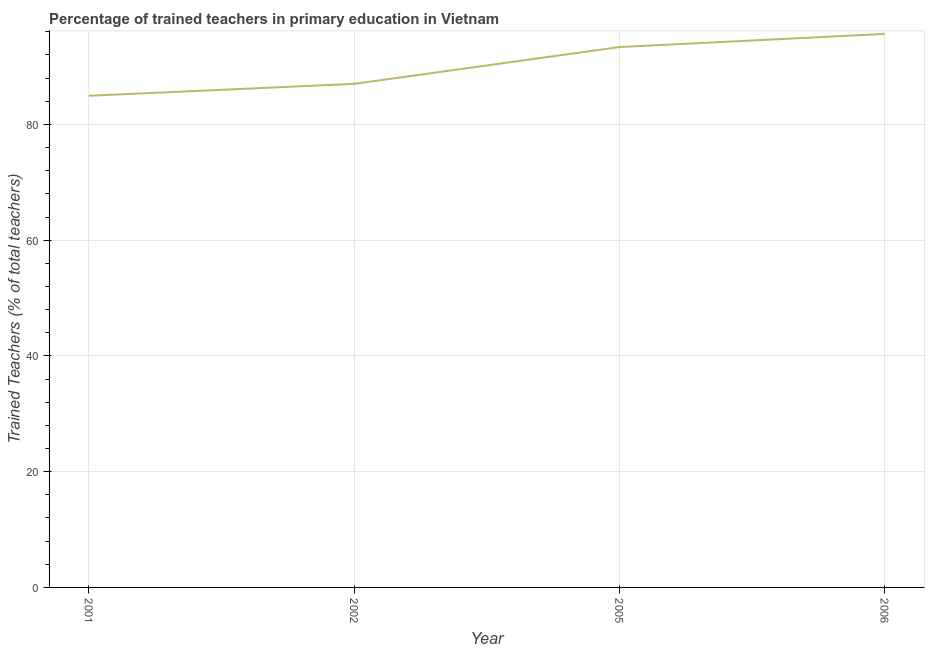What is the percentage of trained teachers in 2002?
Your answer should be compact. 87.01. Across all years, what is the maximum percentage of trained teachers?
Provide a succinct answer. 95.64. Across all years, what is the minimum percentage of trained teachers?
Ensure brevity in your answer.  84.95. In which year was the percentage of trained teachers maximum?
Your answer should be very brief. 2006. In which year was the percentage of trained teachers minimum?
Offer a terse response. 2001. What is the sum of the percentage of trained teachers?
Your answer should be very brief. 360.97. What is the difference between the percentage of trained teachers in 2002 and 2006?
Offer a very short reply. -8.63. What is the average percentage of trained teachers per year?
Provide a succinct answer. 90.24. What is the median percentage of trained teachers?
Give a very brief answer. 90.19. In how many years, is the percentage of trained teachers greater than 40 %?
Your response must be concise. 4. What is the ratio of the percentage of trained teachers in 2001 to that in 2006?
Offer a very short reply. 0.89. Is the percentage of trained teachers in 2002 less than that in 2006?
Provide a succinct answer. Yes. Is the difference between the percentage of trained teachers in 2002 and 2006 greater than the difference between any two years?
Your answer should be compact. No. What is the difference between the highest and the second highest percentage of trained teachers?
Provide a short and direct response. 2.27. Is the sum of the percentage of trained teachers in 2001 and 2005 greater than the maximum percentage of trained teachers across all years?
Offer a very short reply. Yes. What is the difference between the highest and the lowest percentage of trained teachers?
Provide a short and direct response. 10.69. What is the title of the graph?
Your answer should be very brief. Percentage of trained teachers in primary education in Vietnam. What is the label or title of the X-axis?
Make the answer very short. Year. What is the label or title of the Y-axis?
Your answer should be very brief. Trained Teachers (% of total teachers). What is the Trained Teachers (% of total teachers) of 2001?
Your response must be concise. 84.95. What is the Trained Teachers (% of total teachers) of 2002?
Offer a terse response. 87.01. What is the Trained Teachers (% of total teachers) of 2005?
Give a very brief answer. 93.37. What is the Trained Teachers (% of total teachers) in 2006?
Offer a very short reply. 95.64. What is the difference between the Trained Teachers (% of total teachers) in 2001 and 2002?
Your response must be concise. -2.06. What is the difference between the Trained Teachers (% of total teachers) in 2001 and 2005?
Keep it short and to the point. -8.42. What is the difference between the Trained Teachers (% of total teachers) in 2001 and 2006?
Your answer should be compact. -10.69. What is the difference between the Trained Teachers (% of total teachers) in 2002 and 2005?
Give a very brief answer. -6.36. What is the difference between the Trained Teachers (% of total teachers) in 2002 and 2006?
Provide a succinct answer. -8.63. What is the difference between the Trained Teachers (% of total teachers) in 2005 and 2006?
Ensure brevity in your answer.  -2.27. What is the ratio of the Trained Teachers (% of total teachers) in 2001 to that in 2002?
Offer a terse response. 0.98. What is the ratio of the Trained Teachers (% of total teachers) in 2001 to that in 2005?
Your answer should be compact. 0.91. What is the ratio of the Trained Teachers (% of total teachers) in 2001 to that in 2006?
Your answer should be compact. 0.89. What is the ratio of the Trained Teachers (% of total teachers) in 2002 to that in 2005?
Ensure brevity in your answer.  0.93. What is the ratio of the Trained Teachers (% of total teachers) in 2002 to that in 2006?
Your answer should be compact. 0.91. What is the ratio of the Trained Teachers (% of total teachers) in 2005 to that in 2006?
Keep it short and to the point. 0.98. 